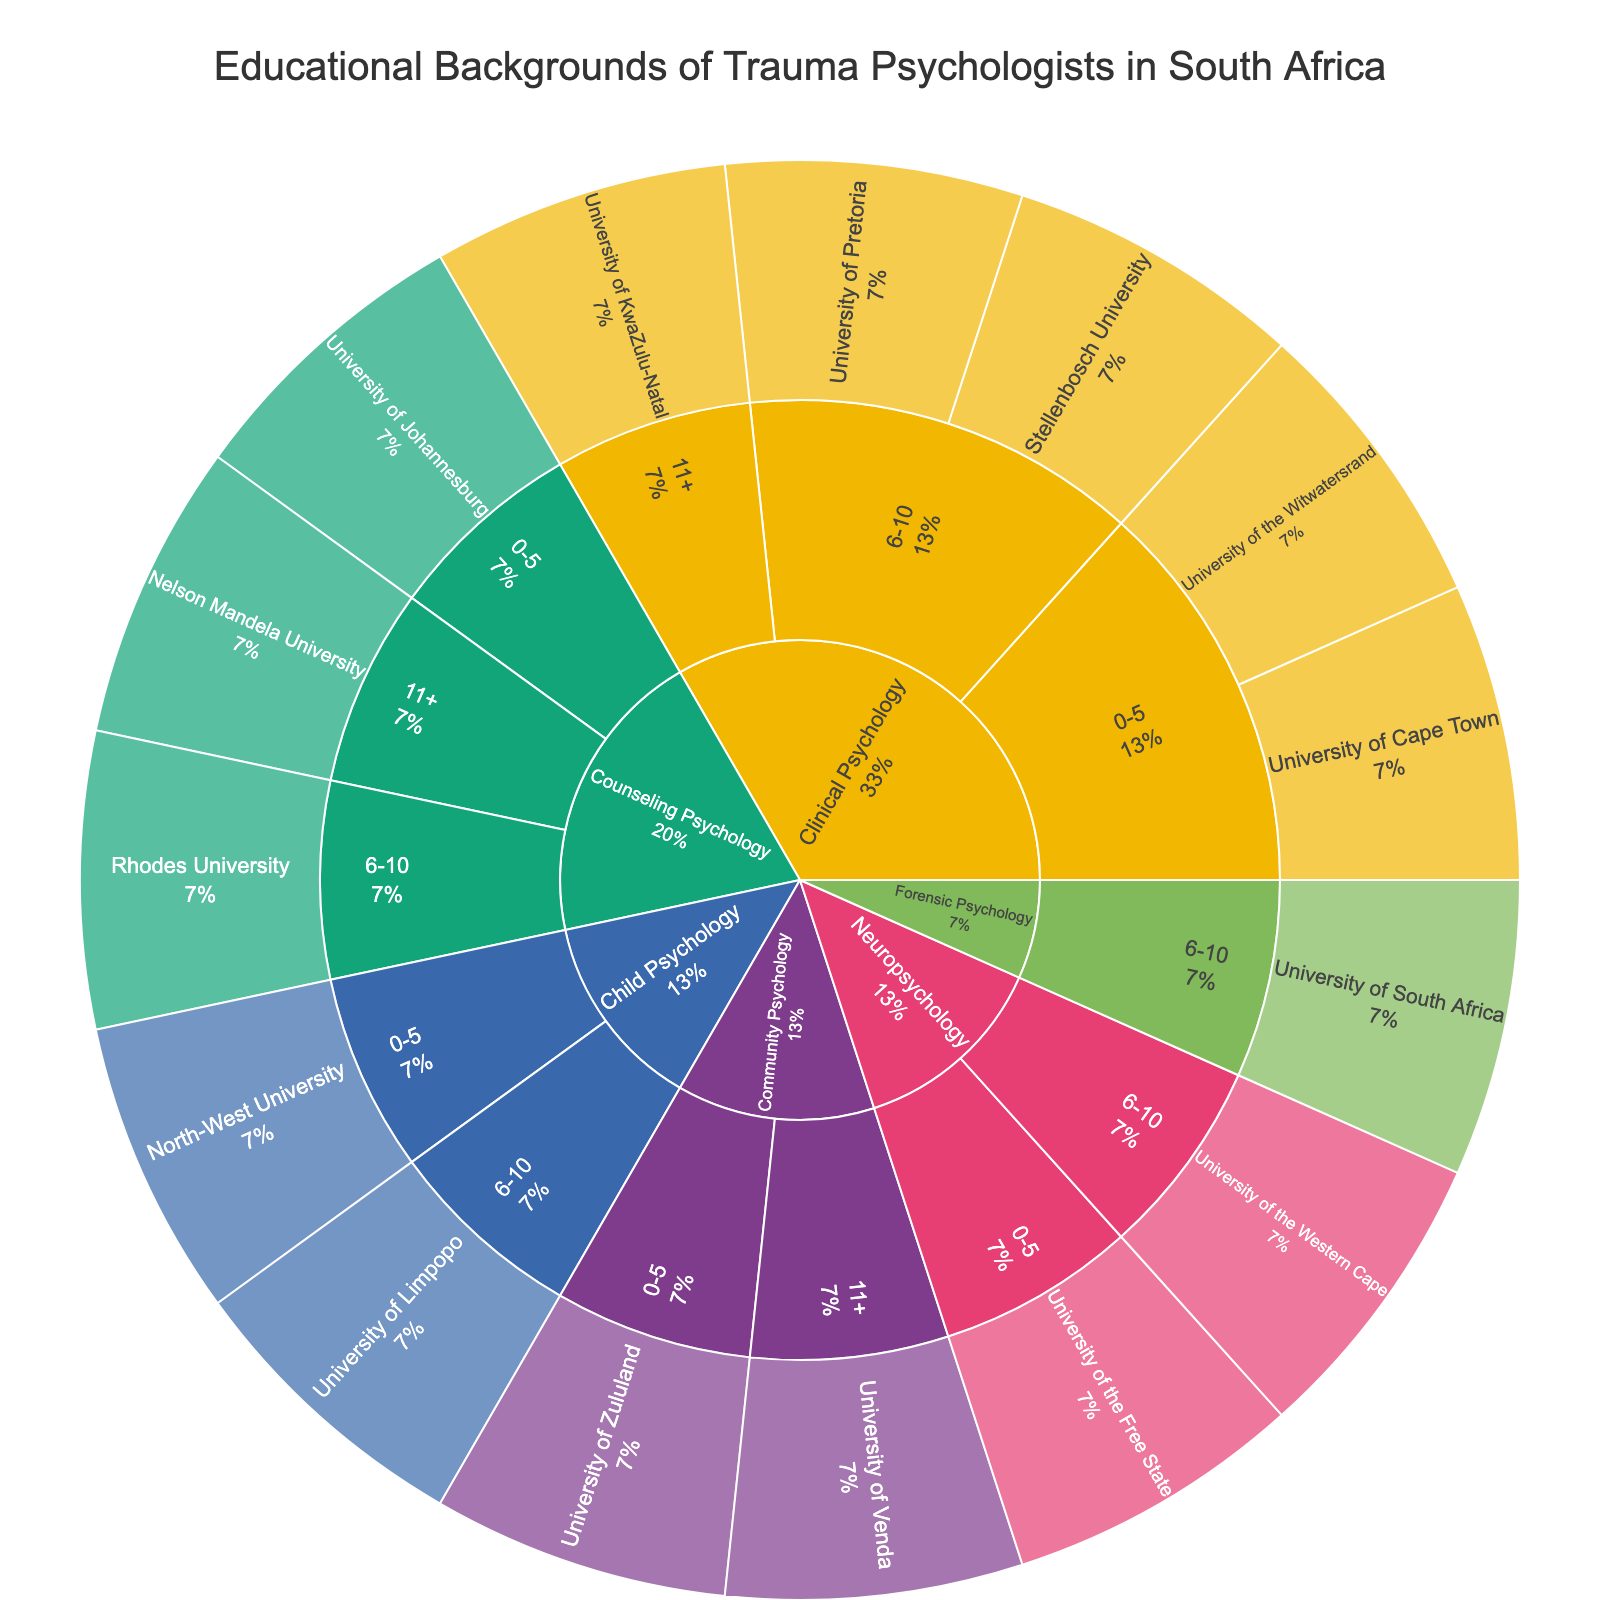What is the title of the sunburst plot? The title is displayed at the top of the figure, providing general information on what the visualization represents. By reading the title, we can understand the context of the data shown.
Answer: Educational Backgrounds of Trauma Psychologists in South Africa Which specialization has the most educational institutions listed? By visually inspecting the plot's segments for each specialization, we can count the number of segments corresponding to different educational institutions. The specialization with the most segments has the most educational institutions listed.
Answer: Clinical Psychology How many educational institutions are represented in the 0-5 years of experience category for Clinical Psychology? Navigate to the segment labeled 'Clinical Psychology' and then to its sub-segment '0-5'. The segments branching off from '0-5' show the educational institutions. Count these segments to get the answer.
Answer: 2 Which specialization has educational backgrounds from North-West University? Identify the segment labeled 'North-West University' and trace back to its parent segment, which indicates the specialization.
Answer: Child Psychology Between Clinical Psychology and Counseling Psychology, which has more psychologists with 6-10 years of experience? Locate the segments for 'Clinical Psychology' and 'Counseling Psychology'. Then find the sub-segments labeled '6-10' under each specialization and compare their sizes or count the institutions within these segments.
Answer: Clinical Psychology What percentage of trauma psychologists in the figure have 11+ years of experience in Community Psychology? Find the segment under 'Community Psychology' labeled '11+' and look for the percentage indicated in this segment.
Answer: The percentage will be shown directly in the segment labeled '11+' under 'Community Psychology' Which educational institution is associated with both 'Neuropsychology' and '6-10' years of experience? Locate the 'Neuropsychology' segment, then find the '6-10' sub-segment. The educational institution associated with this sub-segment will provide the answer.
Answer: University of the Western Cape Is there any specialization that does not have entries for psychologists with 11+ years of experience? Inspect each specialization segment to see if they all have sub-segments labeled '11+'. Identifying any specialization without such a sub-segment will answer the question.
Answer: Yes, Neuropsychology, Child Psychology, Forensic Psychology How does the variety of educational backgrounds in Forensic Psychology compare to other specializations? Look at the segment labeled 'Forensic Psychology' and count the different educational institutions present. Compare this count with the counts of educational institutions in other specializations.
Answer: Forensic Psychology has fewer educational institutions listed How many specializations have psychologists with more than 10 years of experience? Examine each specialization segment for the presence of a sub-segment labeled '11+'. Count all specializations that have this sub-segment.
Answer: 3 